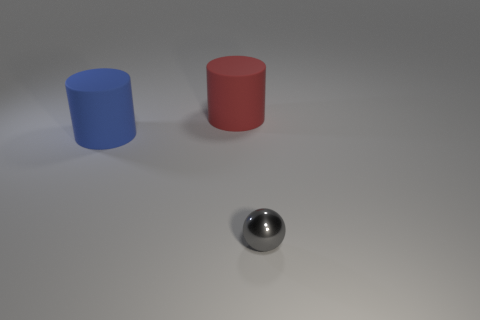Subtract all cylinders. How many objects are left? 1 Add 3 small matte things. How many objects exist? 6 Subtract 0 gray cylinders. How many objects are left? 3 Subtract all cyan shiny things. Subtract all red things. How many objects are left? 2 Add 1 tiny gray spheres. How many tiny gray spheres are left? 2 Add 3 big rubber things. How many big rubber things exist? 5 